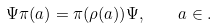<formula> <loc_0><loc_0><loc_500><loc_500>\Psi \pi ( a ) = \pi ( \rho ( a ) ) \Psi , \quad a \in { \AA } .</formula> 